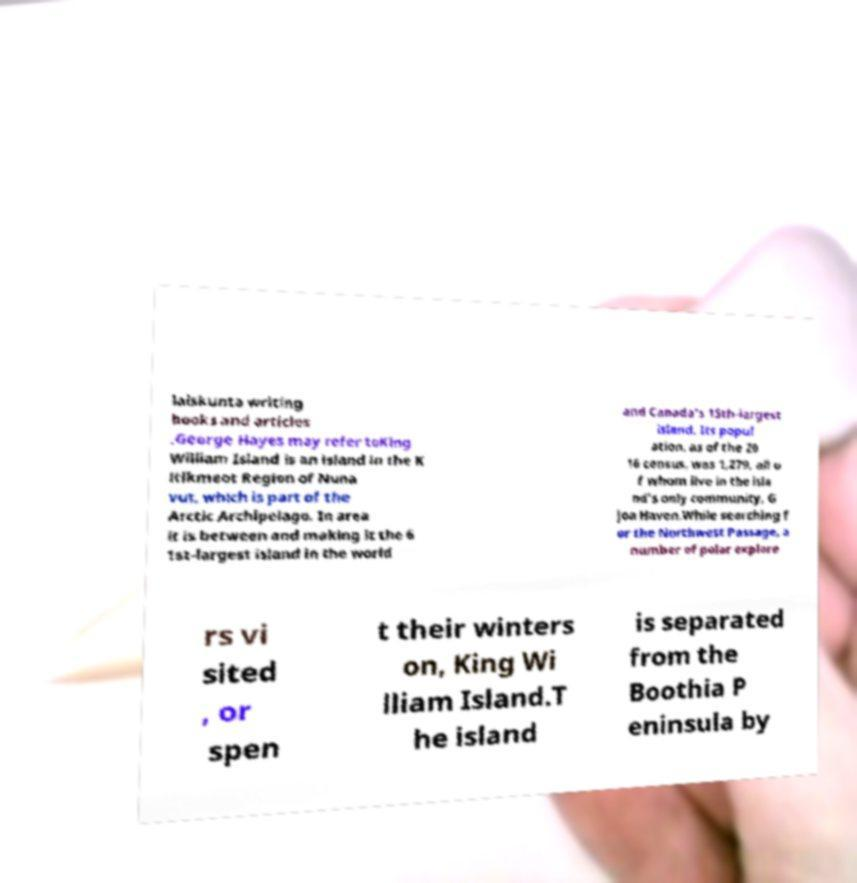Could you assist in decoding the text presented in this image and type it out clearly? laiskunta writing books and articles .George Hayes may refer toKing William Island is an island in the K itikmeot Region of Nuna vut, which is part of the Arctic Archipelago. In area it is between and making it the 6 1st-largest island in the world and Canada's 15th-largest island. Its popul ation, as of the 20 16 census, was 1,279, all o f whom live in the isla nd's only community, G joa Haven.While searching f or the Northwest Passage, a number of polar explore rs vi sited , or spen t their winters on, King Wi lliam Island.T he island is separated from the Boothia P eninsula by 